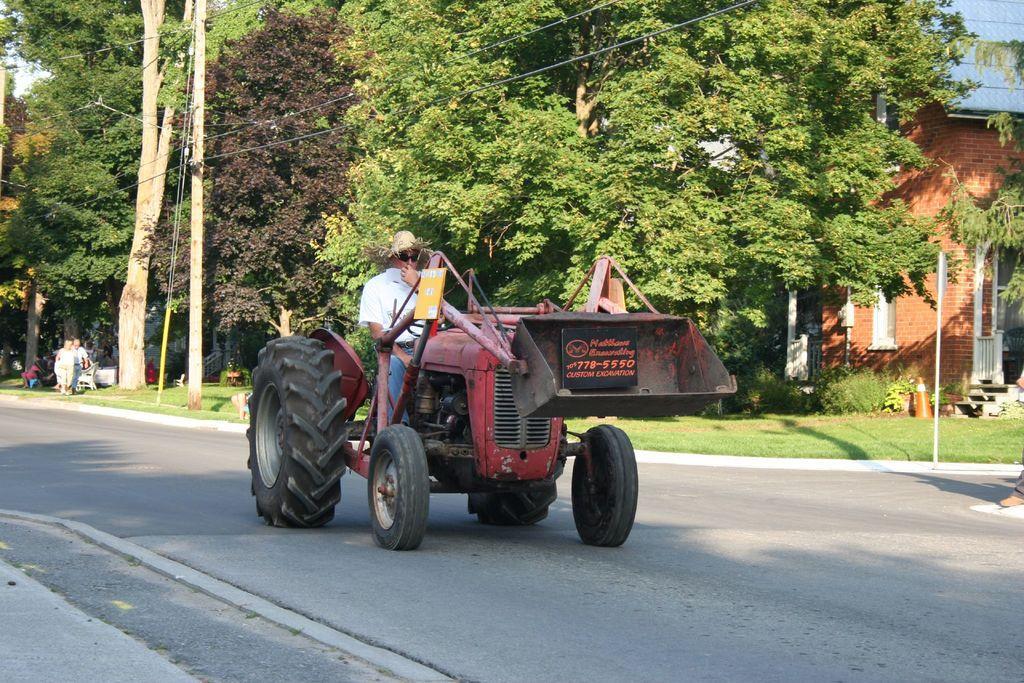How would you summarize this image in a sentence or two? In this picture we can see a person is driving a tractor, in the background there are some trees and a house, on the left side there is a pole, two persons and grass, on the right side we can see a plant and traffic cone. 